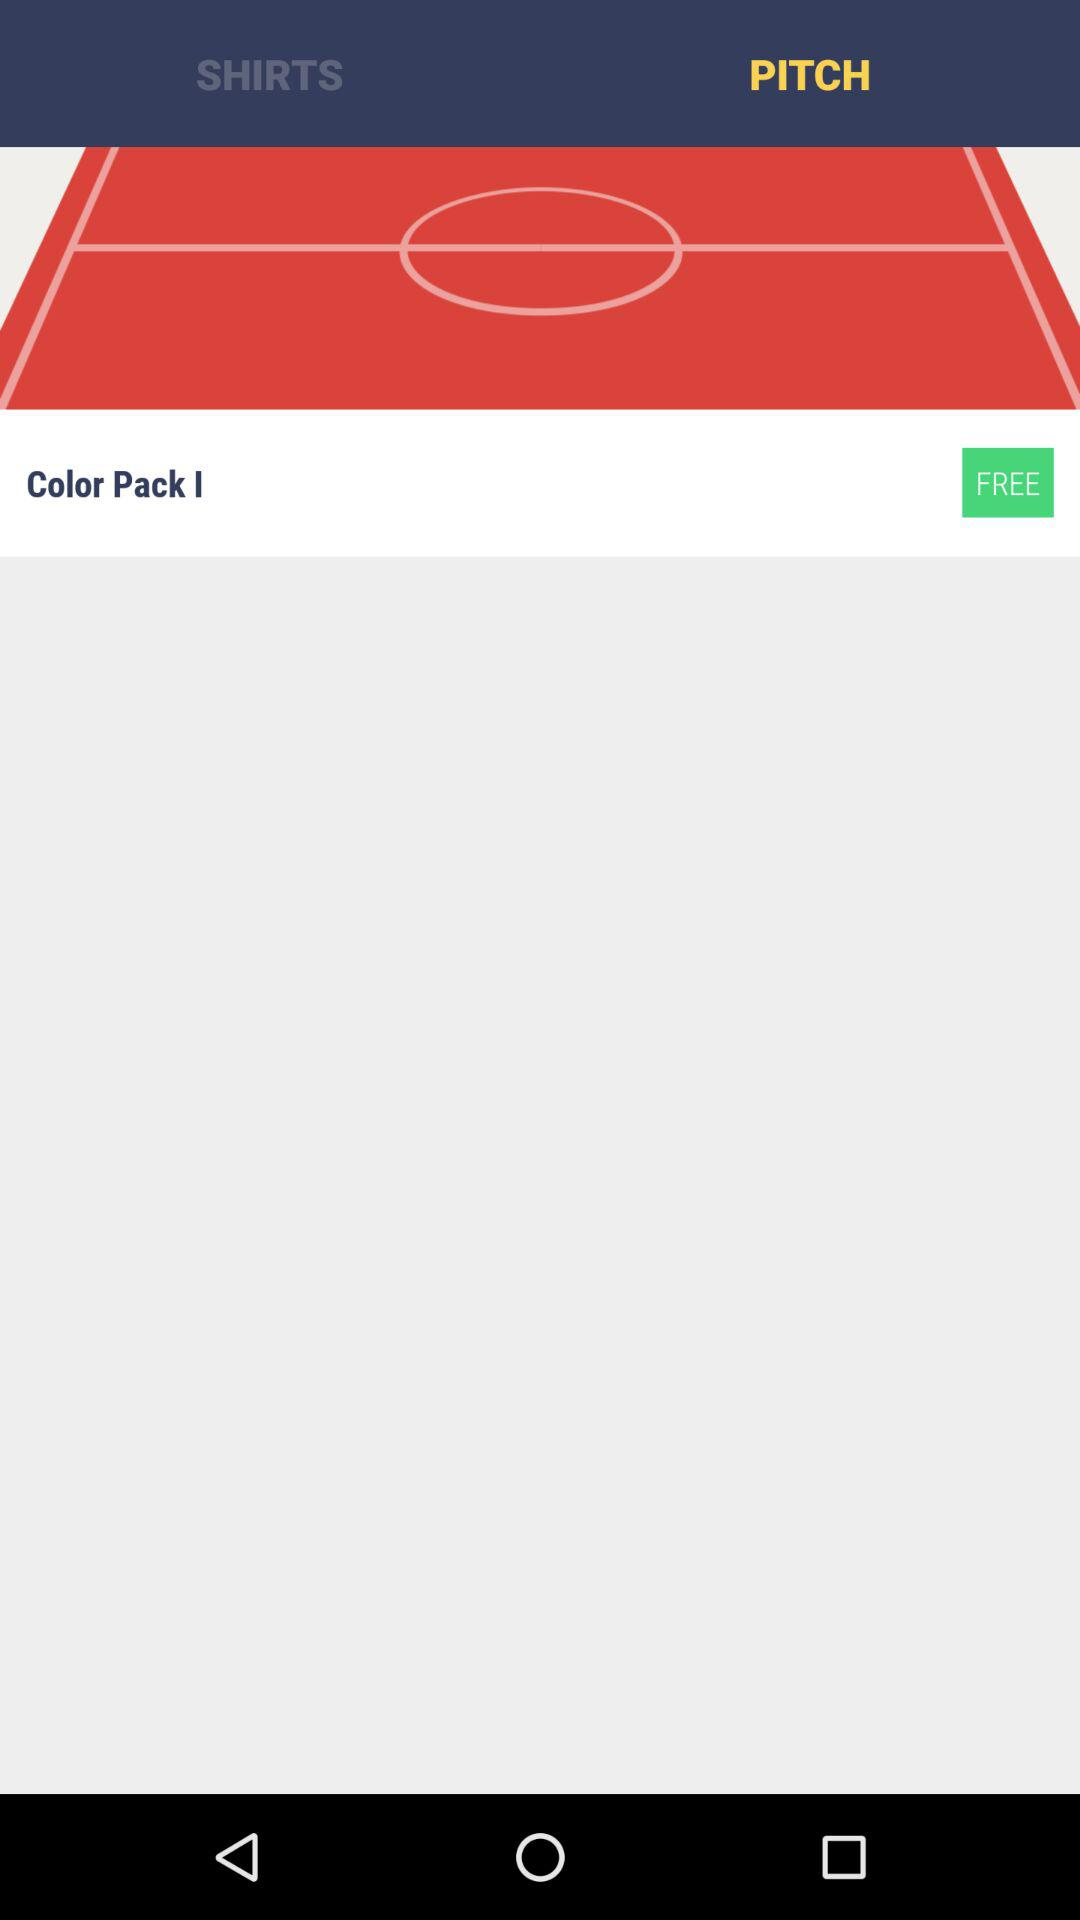What's the color pack number? The color pack number is 1. 